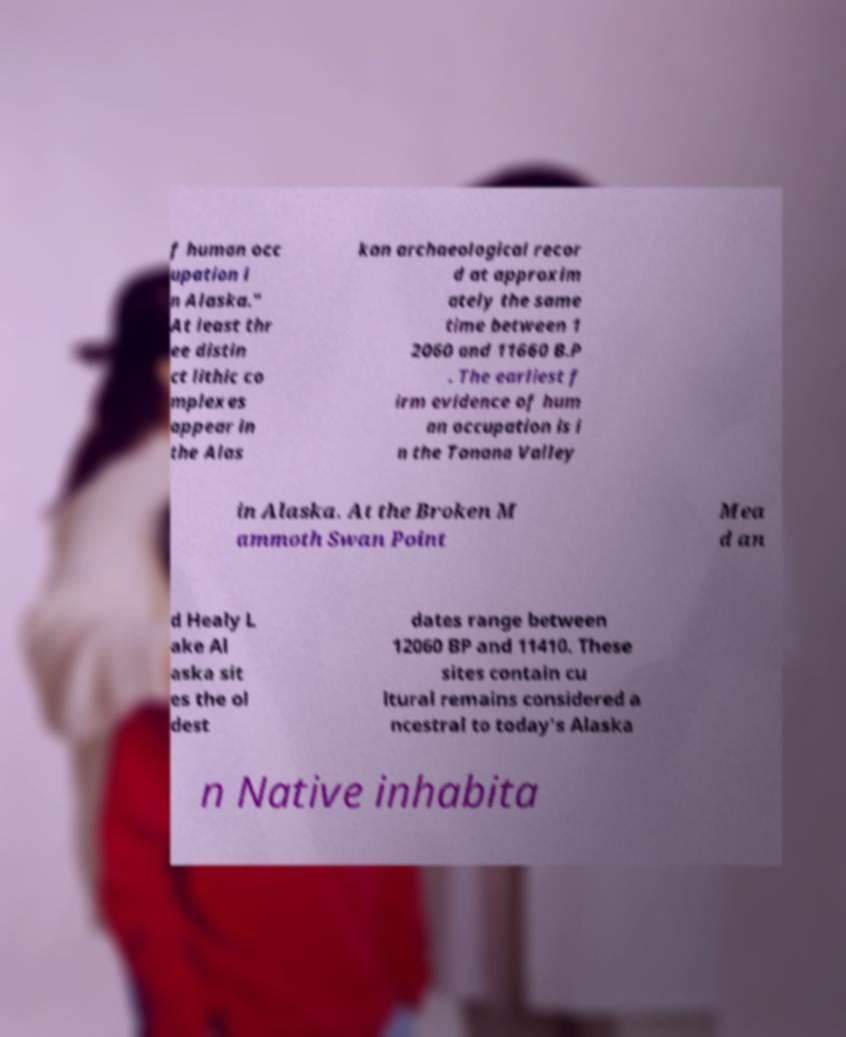Please identify and transcribe the text found in this image. f human occ upation i n Alaska." At least thr ee distin ct lithic co mplexes appear in the Alas kan archaeological recor d at approxim ately the same time between 1 2060 and 11660 B.P . The earliest f irm evidence of hum an occupation is i n the Tanana Valley in Alaska. At the Broken M ammoth Swan Point Mea d an d Healy L ake Al aska sit es the ol dest dates range between 12060 BP and 11410. These sites contain cu ltural remains considered a ncestral to today's Alaska n Native inhabita 